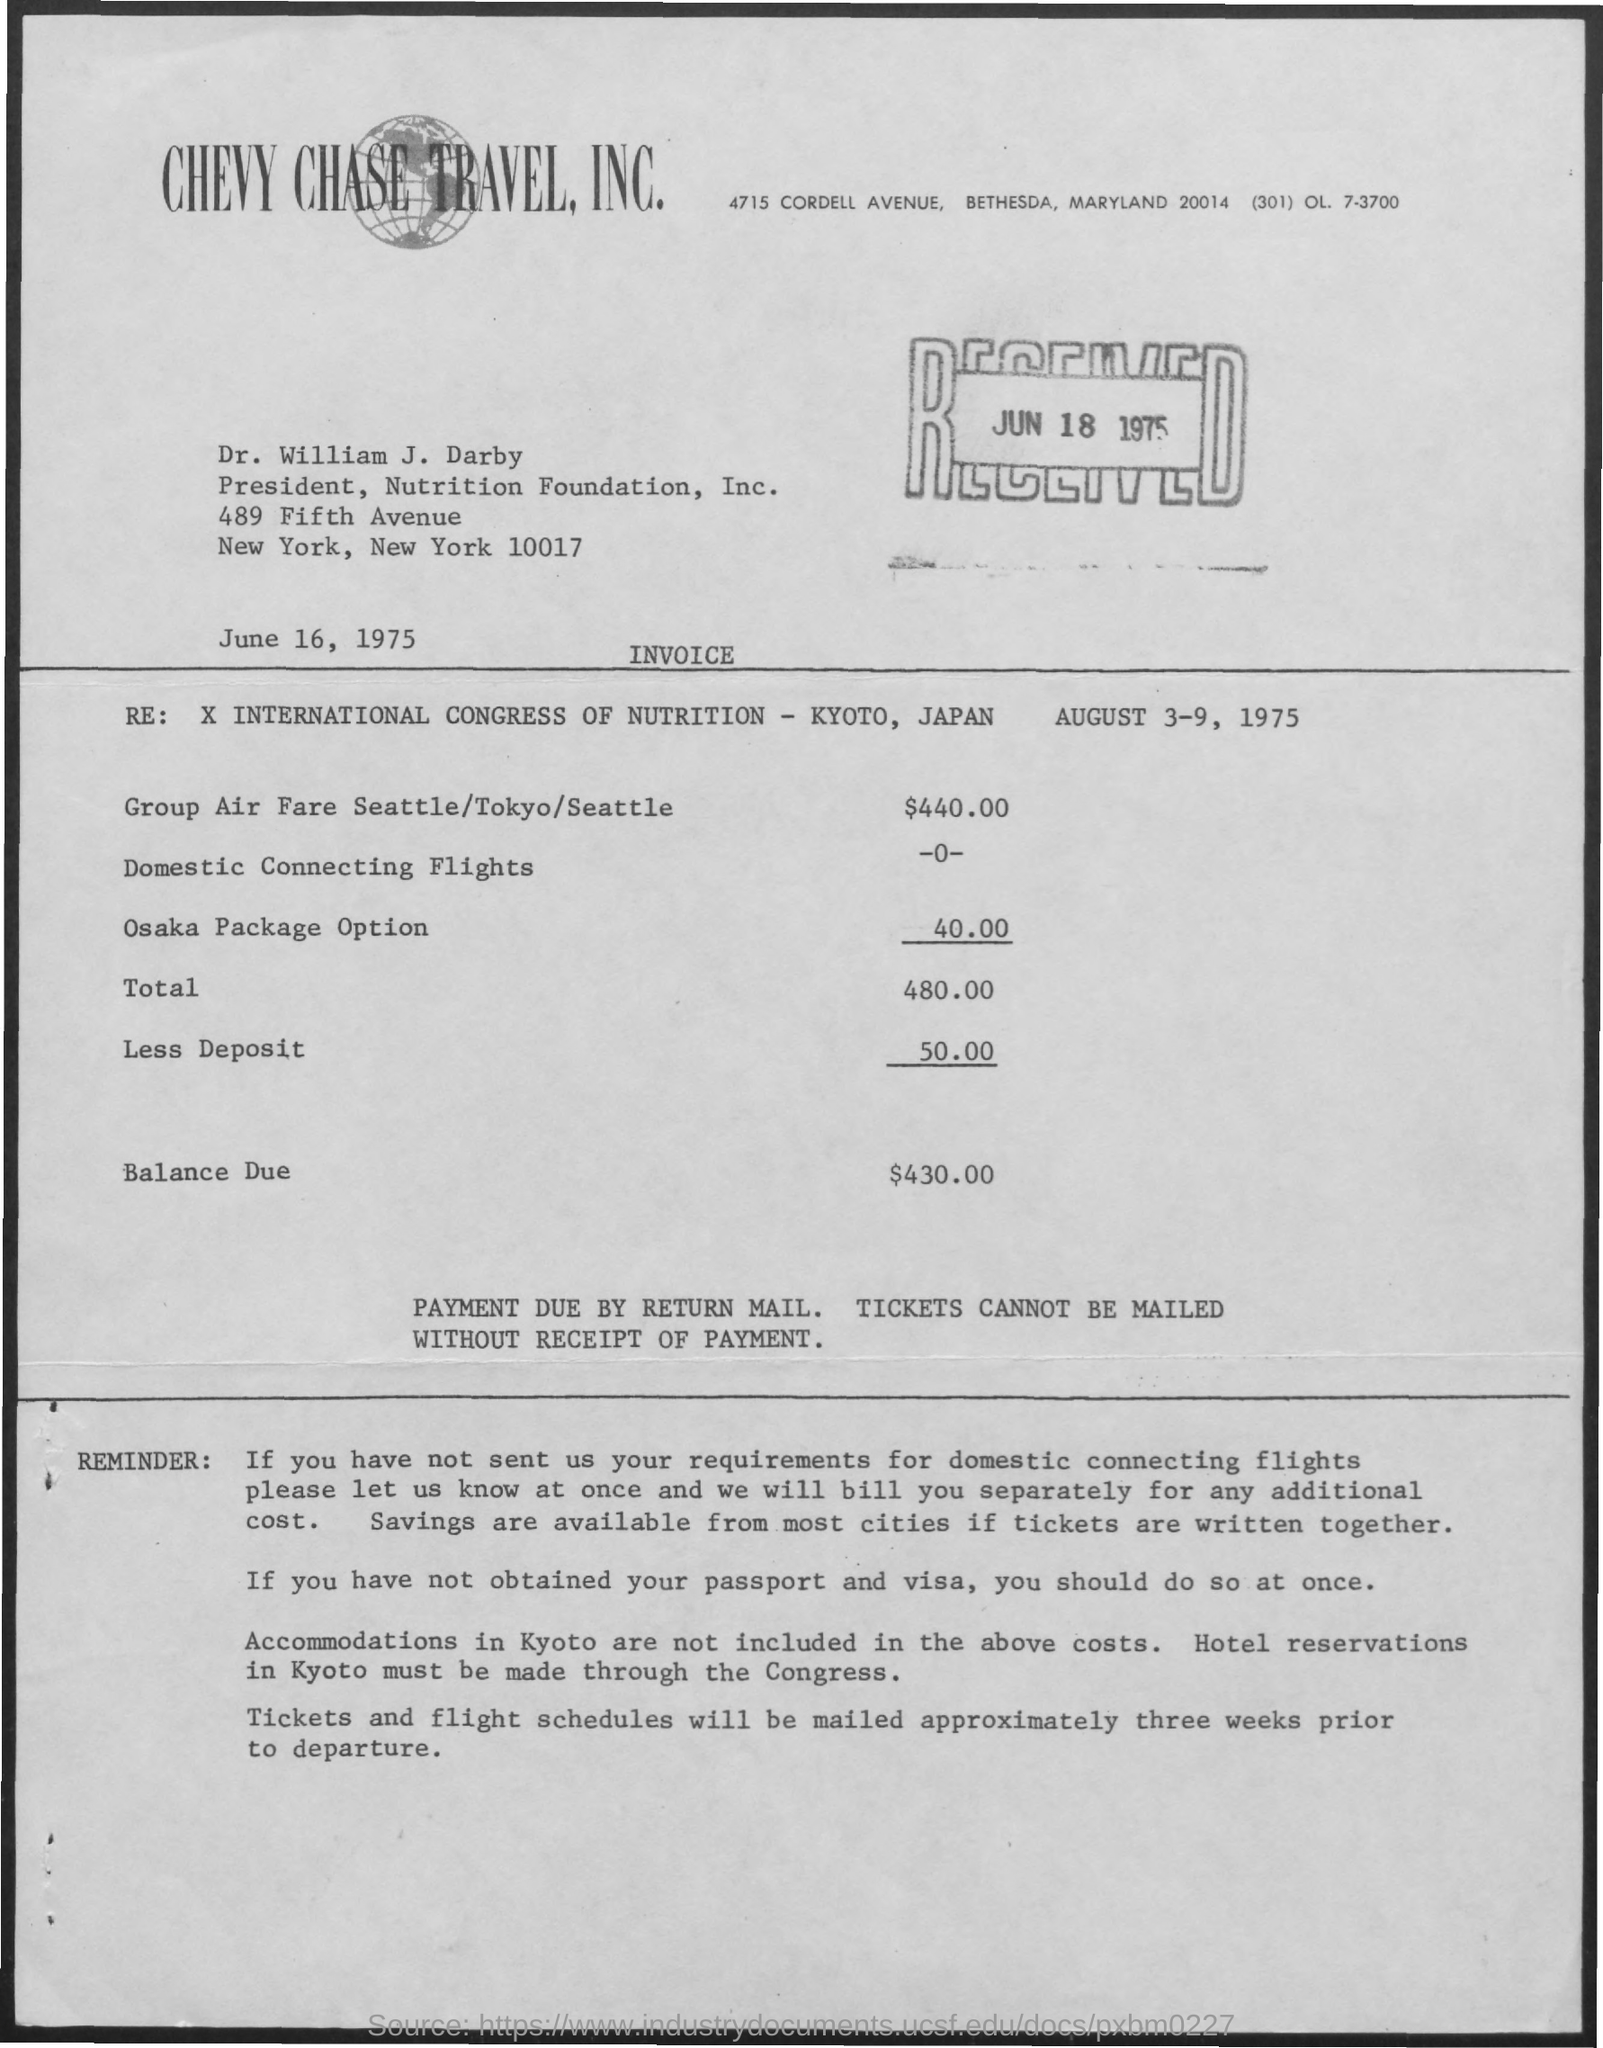What is the cost of Domestic Connecting Flights?
Ensure brevity in your answer.  -0-. Who is the President of Nutrition Foundation, Inc. ?
Your response must be concise. Dr. william j. darby. What is the received date of this invoice?
Make the answer very short. JUN 18 1975. 